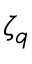Convert formula to latex. <formula><loc_0><loc_0><loc_500><loc_500>\zeta _ { q }</formula> 